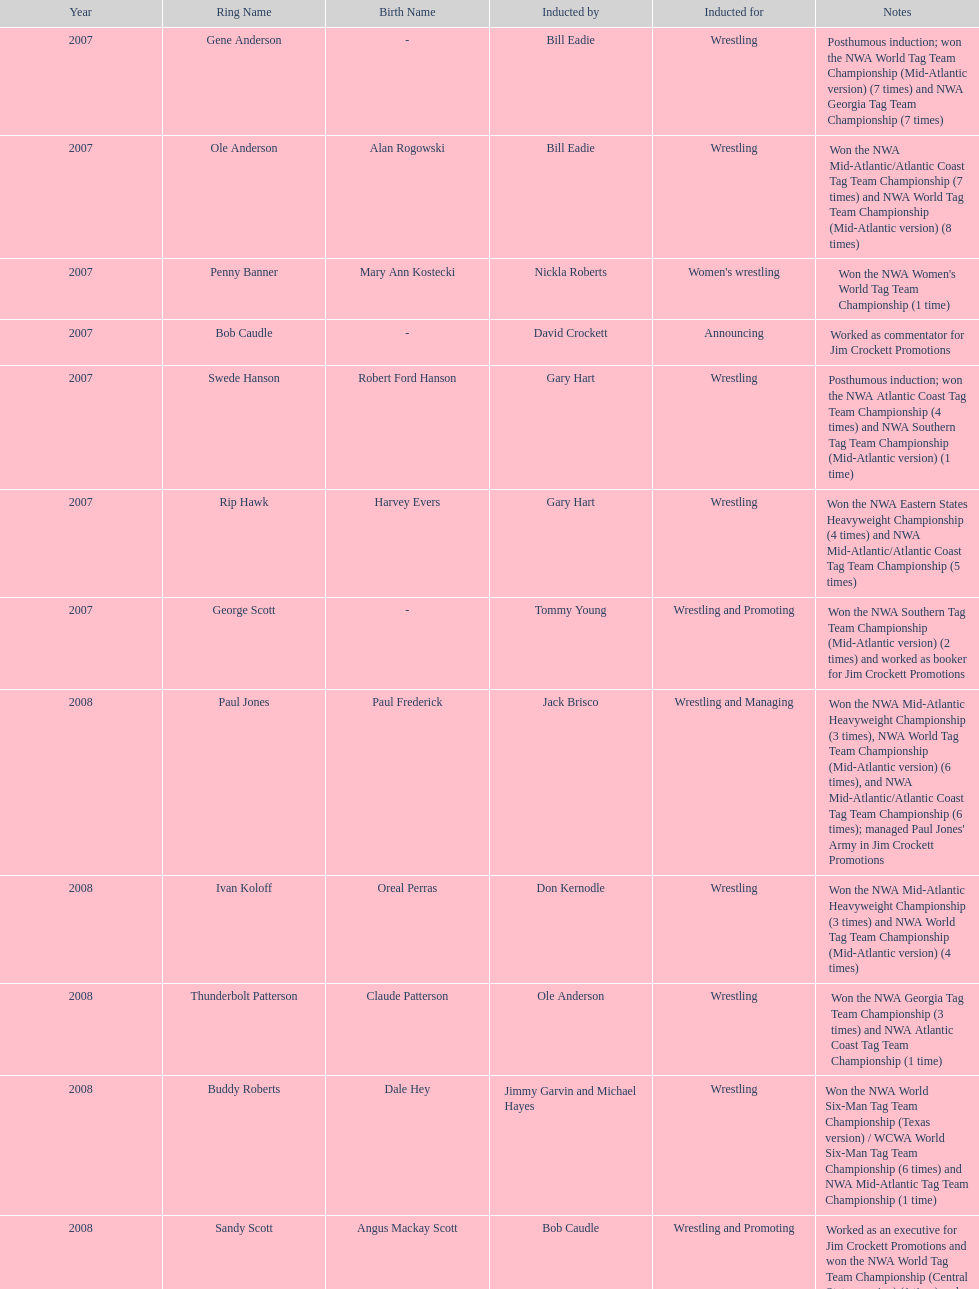Who was the only person to be inducted for wrestling and managing? Paul Jones. 